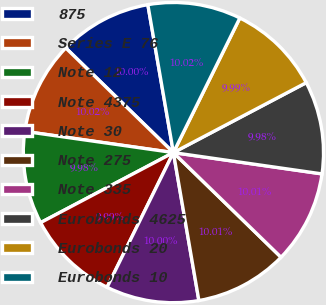<chart> <loc_0><loc_0><loc_500><loc_500><pie_chart><fcel>875<fcel>Series E 76<fcel>Note 12<fcel>Note 4375<fcel>Note 30<fcel>Note 275<fcel>Note 335<fcel>Eurobonds 4625<fcel>Eurobonds 20<fcel>Eurobonds 10<nl><fcel>10.0%<fcel>10.02%<fcel>9.98%<fcel>9.99%<fcel>10.0%<fcel>10.01%<fcel>10.01%<fcel>9.98%<fcel>9.99%<fcel>10.02%<nl></chart> 